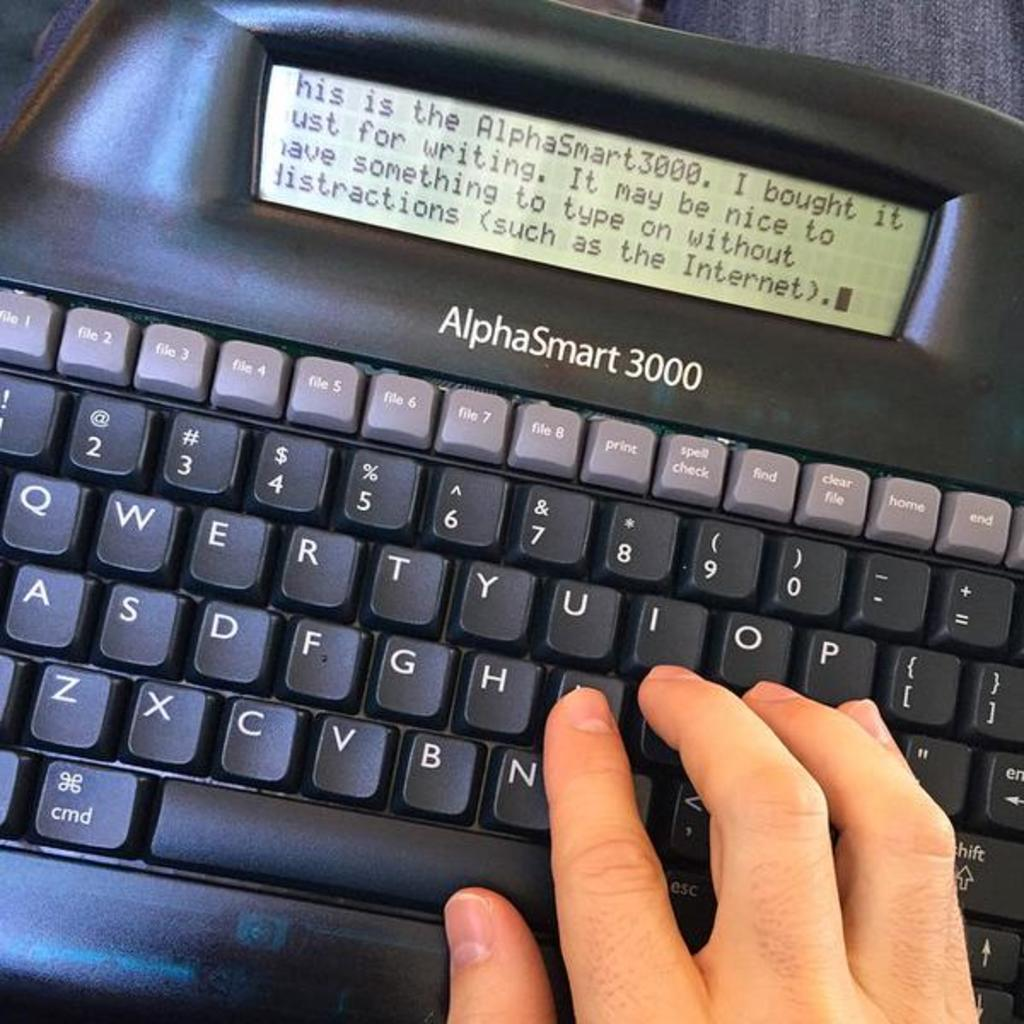<image>
Share a concise interpretation of the image provided. A typewriter with a qwerty keyboard on a rug. 